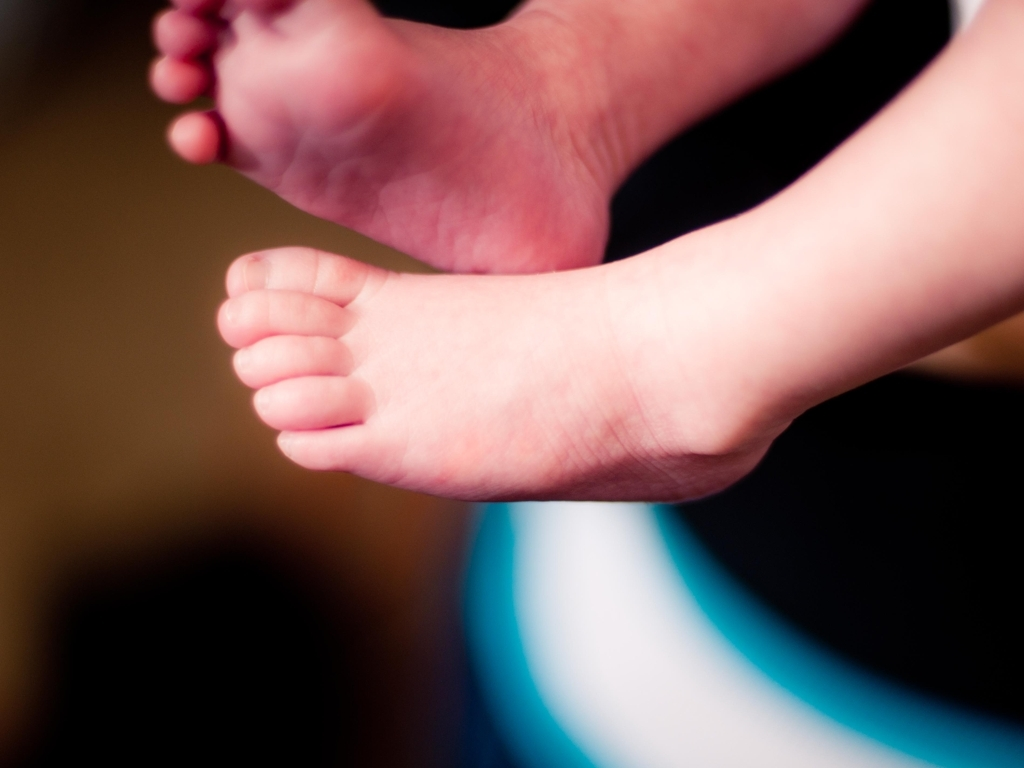Are there any quality issues with this image? The image seems slightly out of focus, primarily around the heel and sole area, which reduces the sharpness and overall clarity. Additionally, there is a noticeable amount of noise and a shallow depth of field that blurs the foreground and background, detracting from the image's potential quality. 